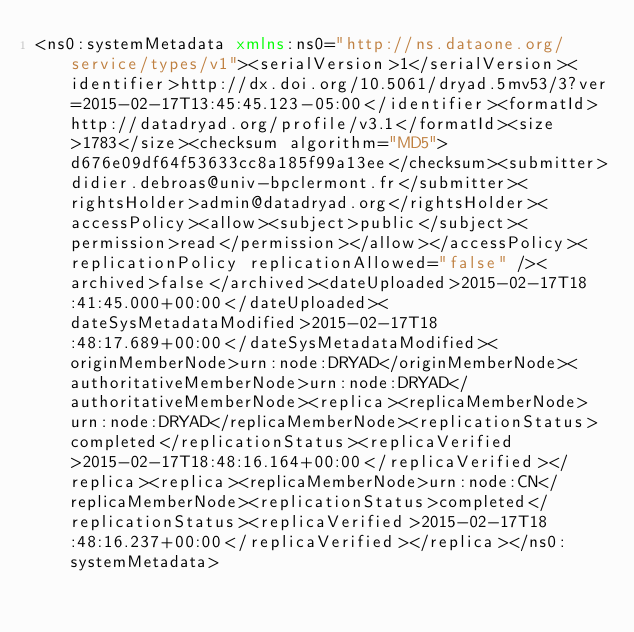Convert code to text. <code><loc_0><loc_0><loc_500><loc_500><_XML_><ns0:systemMetadata xmlns:ns0="http://ns.dataone.org/service/types/v1"><serialVersion>1</serialVersion><identifier>http://dx.doi.org/10.5061/dryad.5mv53/3?ver=2015-02-17T13:45:45.123-05:00</identifier><formatId>http://datadryad.org/profile/v3.1</formatId><size>1783</size><checksum algorithm="MD5">d676e09df64f53633cc8a185f99a13ee</checksum><submitter>didier.debroas@univ-bpclermont.fr</submitter><rightsHolder>admin@datadryad.org</rightsHolder><accessPolicy><allow><subject>public</subject><permission>read</permission></allow></accessPolicy><replicationPolicy replicationAllowed="false" /><archived>false</archived><dateUploaded>2015-02-17T18:41:45.000+00:00</dateUploaded><dateSysMetadataModified>2015-02-17T18:48:17.689+00:00</dateSysMetadataModified><originMemberNode>urn:node:DRYAD</originMemberNode><authoritativeMemberNode>urn:node:DRYAD</authoritativeMemberNode><replica><replicaMemberNode>urn:node:DRYAD</replicaMemberNode><replicationStatus>completed</replicationStatus><replicaVerified>2015-02-17T18:48:16.164+00:00</replicaVerified></replica><replica><replicaMemberNode>urn:node:CN</replicaMemberNode><replicationStatus>completed</replicationStatus><replicaVerified>2015-02-17T18:48:16.237+00:00</replicaVerified></replica></ns0:systemMetadata></code> 